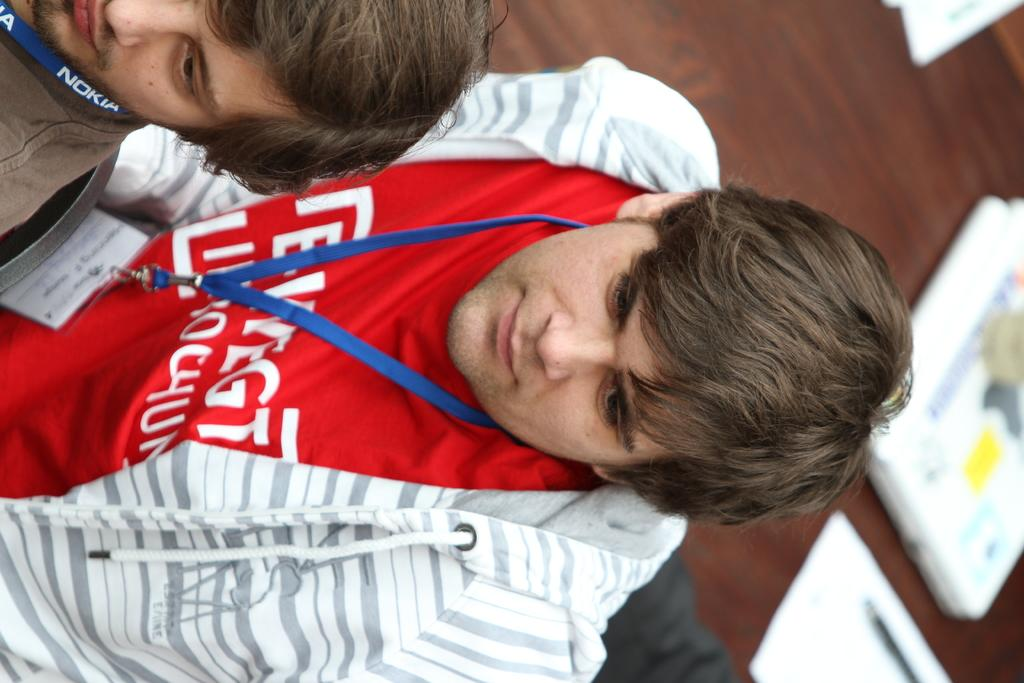<image>
Present a compact description of the photo's key features. A Nokia logo is on a guys lanyard around his neck. 